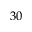<formula> <loc_0><loc_0><loc_500><loc_500>3 0</formula> 